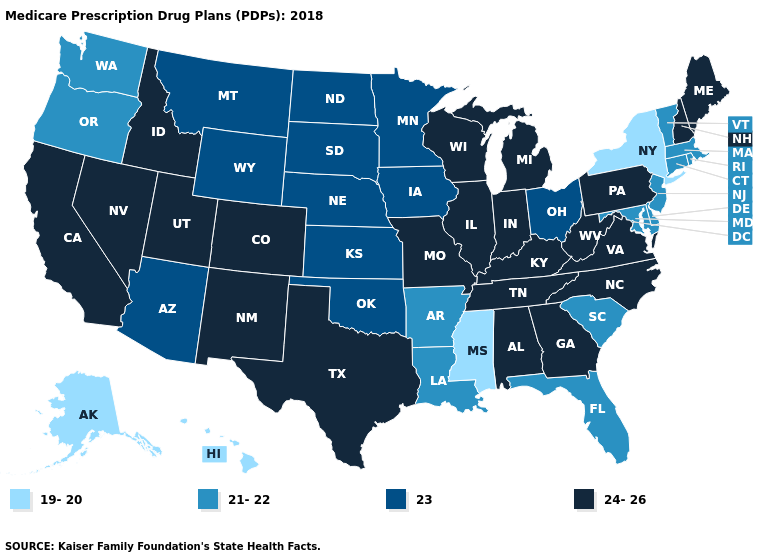Name the states that have a value in the range 23?
Keep it brief. Arizona, Iowa, Kansas, Minnesota, Montana, North Dakota, Nebraska, Ohio, Oklahoma, South Dakota, Wyoming. What is the lowest value in the West?
Concise answer only. 19-20. Does Minnesota have a lower value than Iowa?
Answer briefly. No. Does Iowa have the lowest value in the MidWest?
Be succinct. Yes. Name the states that have a value in the range 23?
Write a very short answer. Arizona, Iowa, Kansas, Minnesota, Montana, North Dakota, Nebraska, Ohio, Oklahoma, South Dakota, Wyoming. What is the value of New Hampshire?
Concise answer only. 24-26. What is the lowest value in states that border Illinois?
Be succinct. 23. Name the states that have a value in the range 24-26?
Quick response, please. Alabama, California, Colorado, Georgia, Idaho, Illinois, Indiana, Kentucky, Maine, Michigan, Missouri, North Carolina, New Hampshire, New Mexico, Nevada, Pennsylvania, Tennessee, Texas, Utah, Virginia, Wisconsin, West Virginia. What is the lowest value in the USA?
Keep it brief. 19-20. Name the states that have a value in the range 21-22?
Answer briefly. Arkansas, Connecticut, Delaware, Florida, Louisiana, Massachusetts, Maryland, New Jersey, Oregon, Rhode Island, South Carolina, Vermont, Washington. What is the value of South Carolina?
Keep it brief. 21-22. What is the value of West Virginia?
Short answer required. 24-26. How many symbols are there in the legend?
Concise answer only. 4. Among the states that border Virginia , does Kentucky have the highest value?
Keep it brief. Yes. Does Alaska have the lowest value in the USA?
Give a very brief answer. Yes. 